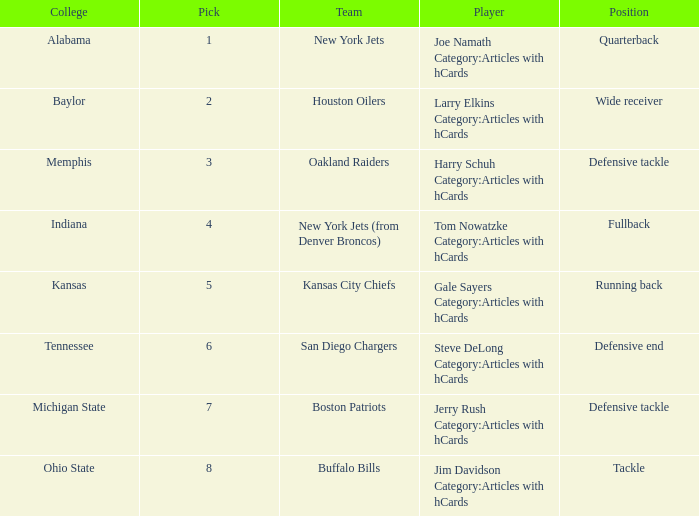Which player is from Ohio State College? Jim Davidson Category:Articles with hCards. 